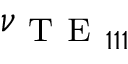<formula> <loc_0><loc_0><loc_500><loc_500>\nu _ { T E _ { 1 1 1 } }</formula> 